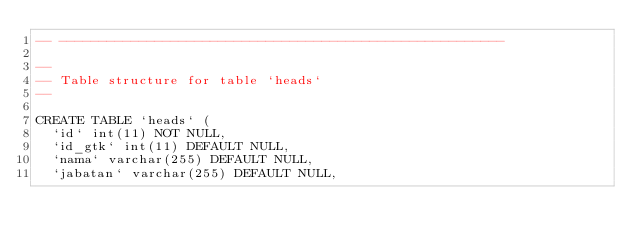Convert code to text. <code><loc_0><loc_0><loc_500><loc_500><_SQL_>-- --------------------------------------------------------

--
-- Table structure for table `heads`
--

CREATE TABLE `heads` (
  `id` int(11) NOT NULL,
  `id_gtk` int(11) DEFAULT NULL,
  `nama` varchar(255) DEFAULT NULL,
  `jabatan` varchar(255) DEFAULT NULL,</code> 